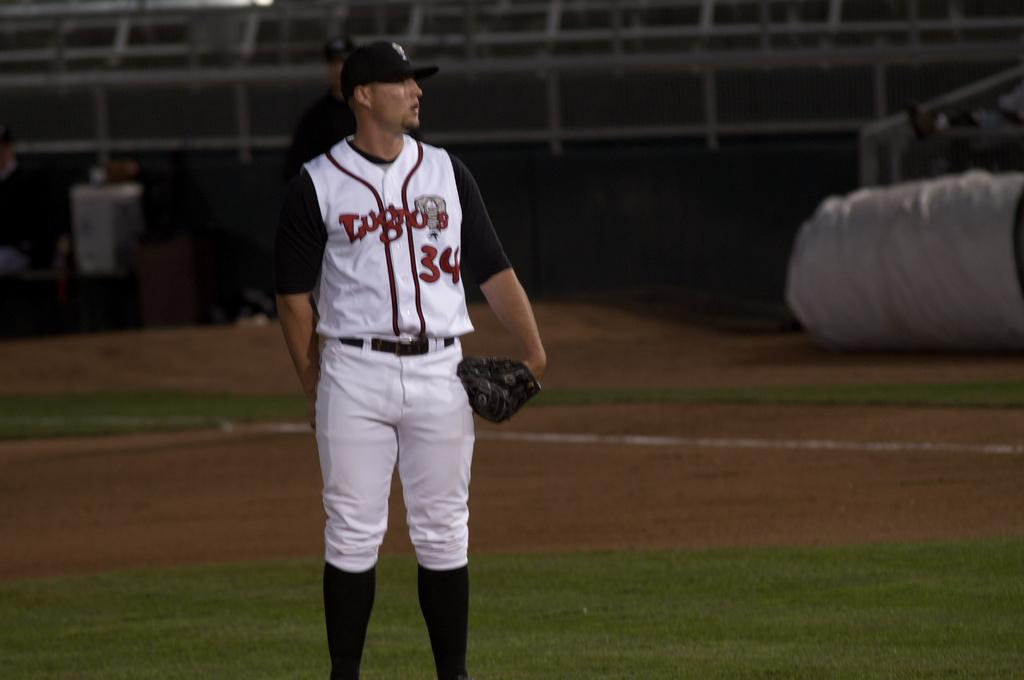<image>
Offer a succinct explanation of the picture presented. A pitcher with 34 on his jersey standing with his glove on. 